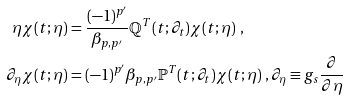<formula> <loc_0><loc_0><loc_500><loc_500>\eta \chi ( t ; \eta ) & = \frac { ( - 1 ) ^ { p ^ { \prime } } } { \beta _ { p , p ^ { \prime } } } \mathbb { Q } ^ { T } ( t ; \partial _ { t } ) \chi ( t ; \eta ) \ , \\ \partial _ { \eta } \chi ( t ; \eta ) & = ( - 1 ) ^ { p ^ { \prime } } \beta _ { p , p ^ { \prime } } \mathbb { P } ^ { T } ( t ; \partial _ { t } ) \chi ( t ; \eta ) \ , \partial _ { \eta } \equiv g _ { s } \frac { \partial } { \partial \eta }</formula> 